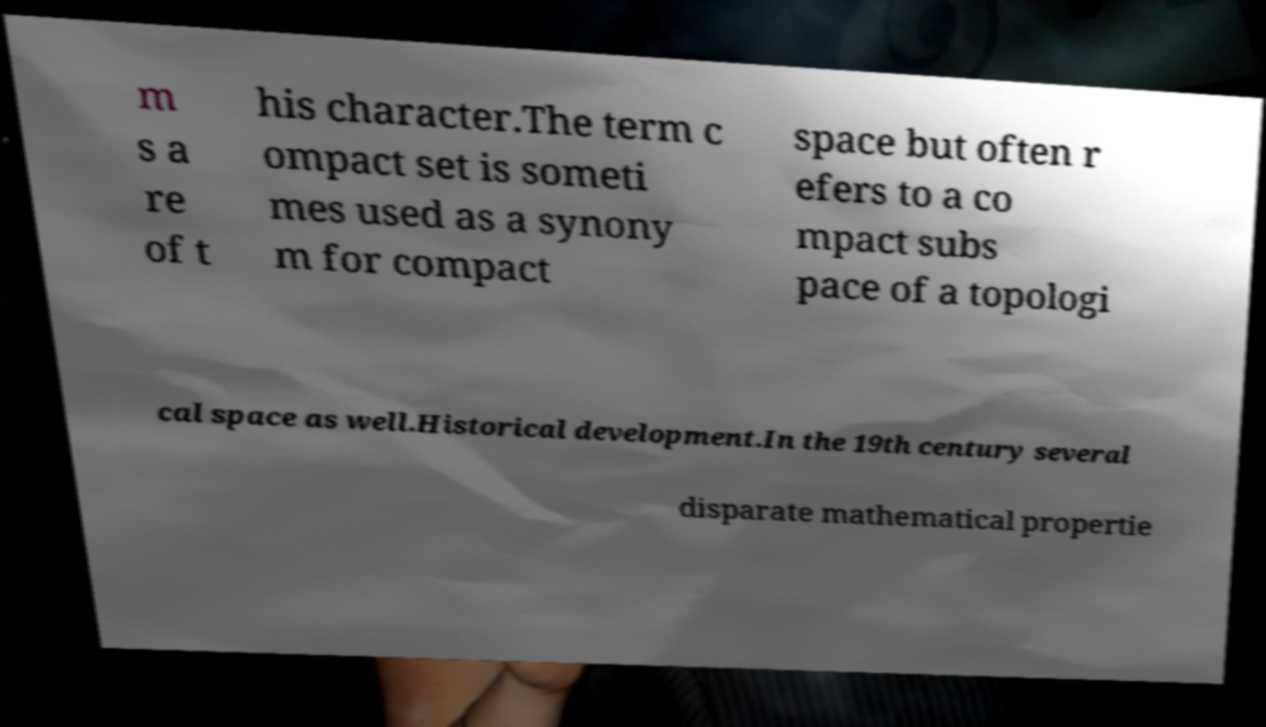Please read and relay the text visible in this image. What does it say? m s a re of t his character.The term c ompact set is someti mes used as a synony m for compact space but often r efers to a co mpact subs pace of a topologi cal space as well.Historical development.In the 19th century several disparate mathematical propertie 